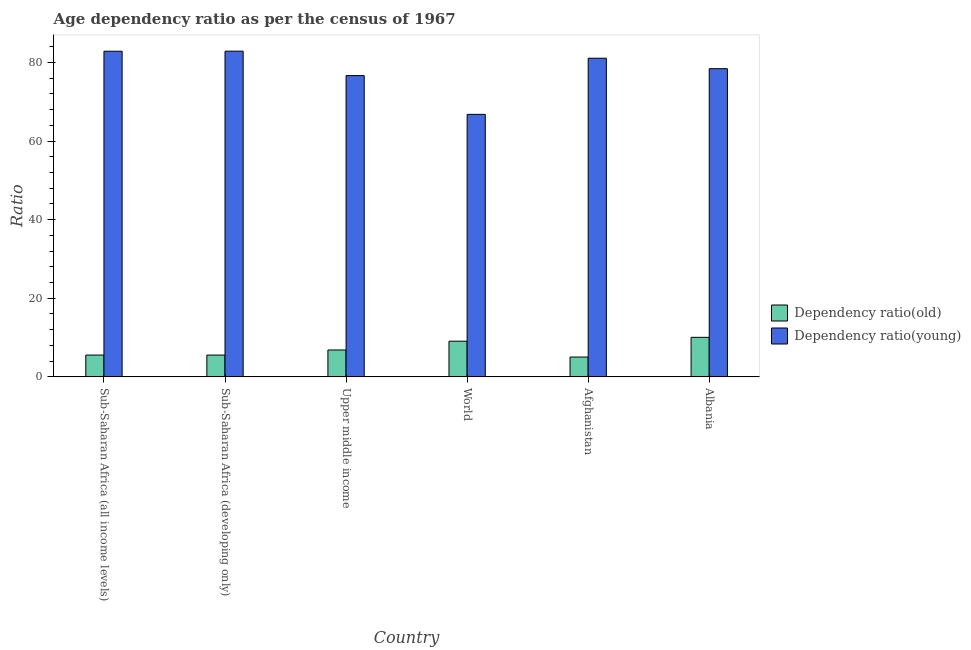How many different coloured bars are there?
Your answer should be very brief. 2. Are the number of bars on each tick of the X-axis equal?
Your answer should be very brief. Yes. How many bars are there on the 2nd tick from the right?
Provide a short and direct response. 2. What is the label of the 3rd group of bars from the left?
Provide a short and direct response. Upper middle income. What is the age dependency ratio(old) in Sub-Saharan Africa (all income levels)?
Your response must be concise. 5.55. Across all countries, what is the maximum age dependency ratio(young)?
Offer a terse response. 82.85. Across all countries, what is the minimum age dependency ratio(young)?
Your answer should be compact. 66.78. In which country was the age dependency ratio(young) maximum?
Your answer should be very brief. Sub-Saharan Africa (developing only). In which country was the age dependency ratio(young) minimum?
Offer a very short reply. World. What is the total age dependency ratio(old) in the graph?
Offer a terse response. 42.12. What is the difference between the age dependency ratio(old) in Upper middle income and that in World?
Keep it short and to the point. -2.24. What is the difference between the age dependency ratio(young) in Afghanistan and the age dependency ratio(old) in World?
Ensure brevity in your answer.  71.98. What is the average age dependency ratio(old) per country?
Make the answer very short. 7.02. What is the difference between the age dependency ratio(young) and age dependency ratio(old) in Upper middle income?
Ensure brevity in your answer.  69.8. In how many countries, is the age dependency ratio(young) greater than 32 ?
Offer a very short reply. 6. What is the ratio of the age dependency ratio(young) in Albania to that in Sub-Saharan Africa (all income levels)?
Offer a terse response. 0.95. Is the difference between the age dependency ratio(old) in Afghanistan and Sub-Saharan Africa (all income levels) greater than the difference between the age dependency ratio(young) in Afghanistan and Sub-Saharan Africa (all income levels)?
Give a very brief answer. Yes. What is the difference between the highest and the second highest age dependency ratio(young)?
Provide a short and direct response. 0.02. What is the difference between the highest and the lowest age dependency ratio(young)?
Provide a short and direct response. 16.08. Is the sum of the age dependency ratio(young) in Afghanistan and Upper middle income greater than the maximum age dependency ratio(old) across all countries?
Provide a short and direct response. Yes. What does the 1st bar from the left in Albania represents?
Provide a succinct answer. Dependency ratio(old). What does the 1st bar from the right in Albania represents?
Keep it short and to the point. Dependency ratio(young). Are all the bars in the graph horizontal?
Offer a very short reply. No. What is the difference between two consecutive major ticks on the Y-axis?
Your answer should be very brief. 20. How many legend labels are there?
Provide a succinct answer. 2. How are the legend labels stacked?
Provide a succinct answer. Vertical. What is the title of the graph?
Provide a short and direct response. Age dependency ratio as per the census of 1967. Does "Under-5(male)" appear as one of the legend labels in the graph?
Provide a short and direct response. No. What is the label or title of the Y-axis?
Make the answer very short. Ratio. What is the Ratio in Dependency ratio(old) in Sub-Saharan Africa (all income levels)?
Keep it short and to the point. 5.55. What is the Ratio of Dependency ratio(young) in Sub-Saharan Africa (all income levels)?
Keep it short and to the point. 82.84. What is the Ratio of Dependency ratio(old) in Sub-Saharan Africa (developing only)?
Give a very brief answer. 5.55. What is the Ratio of Dependency ratio(young) in Sub-Saharan Africa (developing only)?
Your answer should be very brief. 82.85. What is the Ratio of Dependency ratio(old) in Upper middle income?
Provide a succinct answer. 6.84. What is the Ratio of Dependency ratio(young) in Upper middle income?
Your answer should be compact. 76.64. What is the Ratio in Dependency ratio(old) in World?
Make the answer very short. 9.08. What is the Ratio of Dependency ratio(young) in World?
Make the answer very short. 66.78. What is the Ratio of Dependency ratio(old) in Afghanistan?
Your answer should be compact. 5.05. What is the Ratio in Dependency ratio(young) in Afghanistan?
Make the answer very short. 81.06. What is the Ratio of Dependency ratio(old) in Albania?
Offer a very short reply. 10.06. What is the Ratio of Dependency ratio(young) in Albania?
Offer a terse response. 78.4. Across all countries, what is the maximum Ratio in Dependency ratio(old)?
Your answer should be very brief. 10.06. Across all countries, what is the maximum Ratio of Dependency ratio(young)?
Offer a terse response. 82.85. Across all countries, what is the minimum Ratio of Dependency ratio(old)?
Your answer should be compact. 5.05. Across all countries, what is the minimum Ratio in Dependency ratio(young)?
Ensure brevity in your answer.  66.78. What is the total Ratio in Dependency ratio(old) in the graph?
Make the answer very short. 42.12. What is the total Ratio in Dependency ratio(young) in the graph?
Ensure brevity in your answer.  468.57. What is the difference between the Ratio in Dependency ratio(old) in Sub-Saharan Africa (all income levels) and that in Sub-Saharan Africa (developing only)?
Give a very brief answer. 0. What is the difference between the Ratio in Dependency ratio(young) in Sub-Saharan Africa (all income levels) and that in Sub-Saharan Africa (developing only)?
Offer a very short reply. -0.02. What is the difference between the Ratio of Dependency ratio(old) in Sub-Saharan Africa (all income levels) and that in Upper middle income?
Give a very brief answer. -1.29. What is the difference between the Ratio of Dependency ratio(young) in Sub-Saharan Africa (all income levels) and that in Upper middle income?
Your response must be concise. 6.2. What is the difference between the Ratio of Dependency ratio(old) in Sub-Saharan Africa (all income levels) and that in World?
Your answer should be very brief. -3.53. What is the difference between the Ratio of Dependency ratio(young) in Sub-Saharan Africa (all income levels) and that in World?
Your answer should be compact. 16.06. What is the difference between the Ratio in Dependency ratio(old) in Sub-Saharan Africa (all income levels) and that in Afghanistan?
Keep it short and to the point. 0.5. What is the difference between the Ratio in Dependency ratio(young) in Sub-Saharan Africa (all income levels) and that in Afghanistan?
Provide a short and direct response. 1.78. What is the difference between the Ratio in Dependency ratio(old) in Sub-Saharan Africa (all income levels) and that in Albania?
Offer a terse response. -4.51. What is the difference between the Ratio of Dependency ratio(young) in Sub-Saharan Africa (all income levels) and that in Albania?
Offer a terse response. 4.44. What is the difference between the Ratio of Dependency ratio(old) in Sub-Saharan Africa (developing only) and that in Upper middle income?
Offer a very short reply. -1.3. What is the difference between the Ratio of Dependency ratio(young) in Sub-Saharan Africa (developing only) and that in Upper middle income?
Make the answer very short. 6.21. What is the difference between the Ratio in Dependency ratio(old) in Sub-Saharan Africa (developing only) and that in World?
Your answer should be very brief. -3.53. What is the difference between the Ratio in Dependency ratio(young) in Sub-Saharan Africa (developing only) and that in World?
Your response must be concise. 16.08. What is the difference between the Ratio of Dependency ratio(old) in Sub-Saharan Africa (developing only) and that in Afghanistan?
Provide a succinct answer. 0.5. What is the difference between the Ratio of Dependency ratio(young) in Sub-Saharan Africa (developing only) and that in Afghanistan?
Keep it short and to the point. 1.8. What is the difference between the Ratio of Dependency ratio(old) in Sub-Saharan Africa (developing only) and that in Albania?
Offer a very short reply. -4.51. What is the difference between the Ratio of Dependency ratio(young) in Sub-Saharan Africa (developing only) and that in Albania?
Provide a succinct answer. 4.46. What is the difference between the Ratio in Dependency ratio(old) in Upper middle income and that in World?
Ensure brevity in your answer.  -2.24. What is the difference between the Ratio in Dependency ratio(young) in Upper middle income and that in World?
Make the answer very short. 9.86. What is the difference between the Ratio of Dependency ratio(old) in Upper middle income and that in Afghanistan?
Ensure brevity in your answer.  1.79. What is the difference between the Ratio of Dependency ratio(young) in Upper middle income and that in Afghanistan?
Your answer should be compact. -4.42. What is the difference between the Ratio in Dependency ratio(old) in Upper middle income and that in Albania?
Keep it short and to the point. -3.22. What is the difference between the Ratio of Dependency ratio(young) in Upper middle income and that in Albania?
Make the answer very short. -1.76. What is the difference between the Ratio in Dependency ratio(old) in World and that in Afghanistan?
Your answer should be compact. 4.03. What is the difference between the Ratio of Dependency ratio(young) in World and that in Afghanistan?
Provide a succinct answer. -14.28. What is the difference between the Ratio of Dependency ratio(old) in World and that in Albania?
Keep it short and to the point. -0.98. What is the difference between the Ratio of Dependency ratio(young) in World and that in Albania?
Your response must be concise. -11.62. What is the difference between the Ratio of Dependency ratio(old) in Afghanistan and that in Albania?
Your answer should be very brief. -5.01. What is the difference between the Ratio of Dependency ratio(young) in Afghanistan and that in Albania?
Offer a terse response. 2.66. What is the difference between the Ratio of Dependency ratio(old) in Sub-Saharan Africa (all income levels) and the Ratio of Dependency ratio(young) in Sub-Saharan Africa (developing only)?
Ensure brevity in your answer.  -77.3. What is the difference between the Ratio in Dependency ratio(old) in Sub-Saharan Africa (all income levels) and the Ratio in Dependency ratio(young) in Upper middle income?
Your response must be concise. -71.09. What is the difference between the Ratio of Dependency ratio(old) in Sub-Saharan Africa (all income levels) and the Ratio of Dependency ratio(young) in World?
Offer a very short reply. -61.23. What is the difference between the Ratio in Dependency ratio(old) in Sub-Saharan Africa (all income levels) and the Ratio in Dependency ratio(young) in Afghanistan?
Keep it short and to the point. -75.51. What is the difference between the Ratio of Dependency ratio(old) in Sub-Saharan Africa (all income levels) and the Ratio of Dependency ratio(young) in Albania?
Provide a short and direct response. -72.85. What is the difference between the Ratio of Dependency ratio(old) in Sub-Saharan Africa (developing only) and the Ratio of Dependency ratio(young) in Upper middle income?
Ensure brevity in your answer.  -71.09. What is the difference between the Ratio in Dependency ratio(old) in Sub-Saharan Africa (developing only) and the Ratio in Dependency ratio(young) in World?
Offer a very short reply. -61.23. What is the difference between the Ratio of Dependency ratio(old) in Sub-Saharan Africa (developing only) and the Ratio of Dependency ratio(young) in Afghanistan?
Give a very brief answer. -75.51. What is the difference between the Ratio of Dependency ratio(old) in Sub-Saharan Africa (developing only) and the Ratio of Dependency ratio(young) in Albania?
Your answer should be very brief. -72.85. What is the difference between the Ratio in Dependency ratio(old) in Upper middle income and the Ratio in Dependency ratio(young) in World?
Your response must be concise. -59.94. What is the difference between the Ratio of Dependency ratio(old) in Upper middle income and the Ratio of Dependency ratio(young) in Afghanistan?
Your response must be concise. -74.22. What is the difference between the Ratio of Dependency ratio(old) in Upper middle income and the Ratio of Dependency ratio(young) in Albania?
Your response must be concise. -71.56. What is the difference between the Ratio of Dependency ratio(old) in World and the Ratio of Dependency ratio(young) in Afghanistan?
Your answer should be very brief. -71.98. What is the difference between the Ratio in Dependency ratio(old) in World and the Ratio in Dependency ratio(young) in Albania?
Offer a terse response. -69.32. What is the difference between the Ratio of Dependency ratio(old) in Afghanistan and the Ratio of Dependency ratio(young) in Albania?
Offer a very short reply. -73.35. What is the average Ratio of Dependency ratio(old) per country?
Give a very brief answer. 7.02. What is the average Ratio of Dependency ratio(young) per country?
Ensure brevity in your answer.  78.09. What is the difference between the Ratio of Dependency ratio(old) and Ratio of Dependency ratio(young) in Sub-Saharan Africa (all income levels)?
Give a very brief answer. -77.29. What is the difference between the Ratio in Dependency ratio(old) and Ratio in Dependency ratio(young) in Sub-Saharan Africa (developing only)?
Provide a succinct answer. -77.31. What is the difference between the Ratio of Dependency ratio(old) and Ratio of Dependency ratio(young) in Upper middle income?
Keep it short and to the point. -69.8. What is the difference between the Ratio in Dependency ratio(old) and Ratio in Dependency ratio(young) in World?
Keep it short and to the point. -57.7. What is the difference between the Ratio of Dependency ratio(old) and Ratio of Dependency ratio(young) in Afghanistan?
Offer a very short reply. -76.01. What is the difference between the Ratio in Dependency ratio(old) and Ratio in Dependency ratio(young) in Albania?
Provide a succinct answer. -68.34. What is the ratio of the Ratio of Dependency ratio(old) in Sub-Saharan Africa (all income levels) to that in Sub-Saharan Africa (developing only)?
Provide a short and direct response. 1. What is the ratio of the Ratio in Dependency ratio(old) in Sub-Saharan Africa (all income levels) to that in Upper middle income?
Offer a very short reply. 0.81. What is the ratio of the Ratio of Dependency ratio(young) in Sub-Saharan Africa (all income levels) to that in Upper middle income?
Your answer should be compact. 1.08. What is the ratio of the Ratio of Dependency ratio(old) in Sub-Saharan Africa (all income levels) to that in World?
Provide a succinct answer. 0.61. What is the ratio of the Ratio in Dependency ratio(young) in Sub-Saharan Africa (all income levels) to that in World?
Your response must be concise. 1.24. What is the ratio of the Ratio of Dependency ratio(old) in Sub-Saharan Africa (all income levels) to that in Afghanistan?
Provide a short and direct response. 1.1. What is the ratio of the Ratio of Dependency ratio(young) in Sub-Saharan Africa (all income levels) to that in Afghanistan?
Keep it short and to the point. 1.02. What is the ratio of the Ratio of Dependency ratio(old) in Sub-Saharan Africa (all income levels) to that in Albania?
Your response must be concise. 0.55. What is the ratio of the Ratio of Dependency ratio(young) in Sub-Saharan Africa (all income levels) to that in Albania?
Ensure brevity in your answer.  1.06. What is the ratio of the Ratio of Dependency ratio(old) in Sub-Saharan Africa (developing only) to that in Upper middle income?
Provide a short and direct response. 0.81. What is the ratio of the Ratio of Dependency ratio(young) in Sub-Saharan Africa (developing only) to that in Upper middle income?
Keep it short and to the point. 1.08. What is the ratio of the Ratio of Dependency ratio(old) in Sub-Saharan Africa (developing only) to that in World?
Your answer should be very brief. 0.61. What is the ratio of the Ratio of Dependency ratio(young) in Sub-Saharan Africa (developing only) to that in World?
Offer a terse response. 1.24. What is the ratio of the Ratio of Dependency ratio(old) in Sub-Saharan Africa (developing only) to that in Afghanistan?
Your response must be concise. 1.1. What is the ratio of the Ratio of Dependency ratio(young) in Sub-Saharan Africa (developing only) to that in Afghanistan?
Make the answer very short. 1.02. What is the ratio of the Ratio in Dependency ratio(old) in Sub-Saharan Africa (developing only) to that in Albania?
Provide a succinct answer. 0.55. What is the ratio of the Ratio of Dependency ratio(young) in Sub-Saharan Africa (developing only) to that in Albania?
Your answer should be very brief. 1.06. What is the ratio of the Ratio in Dependency ratio(old) in Upper middle income to that in World?
Give a very brief answer. 0.75. What is the ratio of the Ratio in Dependency ratio(young) in Upper middle income to that in World?
Offer a very short reply. 1.15. What is the ratio of the Ratio of Dependency ratio(old) in Upper middle income to that in Afghanistan?
Give a very brief answer. 1.36. What is the ratio of the Ratio in Dependency ratio(young) in Upper middle income to that in Afghanistan?
Your answer should be very brief. 0.95. What is the ratio of the Ratio of Dependency ratio(old) in Upper middle income to that in Albania?
Ensure brevity in your answer.  0.68. What is the ratio of the Ratio in Dependency ratio(young) in Upper middle income to that in Albania?
Make the answer very short. 0.98. What is the ratio of the Ratio of Dependency ratio(old) in World to that in Afghanistan?
Keep it short and to the point. 1.8. What is the ratio of the Ratio of Dependency ratio(young) in World to that in Afghanistan?
Keep it short and to the point. 0.82. What is the ratio of the Ratio in Dependency ratio(old) in World to that in Albania?
Give a very brief answer. 0.9. What is the ratio of the Ratio of Dependency ratio(young) in World to that in Albania?
Keep it short and to the point. 0.85. What is the ratio of the Ratio in Dependency ratio(old) in Afghanistan to that in Albania?
Ensure brevity in your answer.  0.5. What is the ratio of the Ratio in Dependency ratio(young) in Afghanistan to that in Albania?
Make the answer very short. 1.03. What is the difference between the highest and the second highest Ratio in Dependency ratio(old)?
Provide a short and direct response. 0.98. What is the difference between the highest and the second highest Ratio in Dependency ratio(young)?
Your response must be concise. 0.02. What is the difference between the highest and the lowest Ratio of Dependency ratio(old)?
Offer a terse response. 5.01. What is the difference between the highest and the lowest Ratio of Dependency ratio(young)?
Make the answer very short. 16.08. 